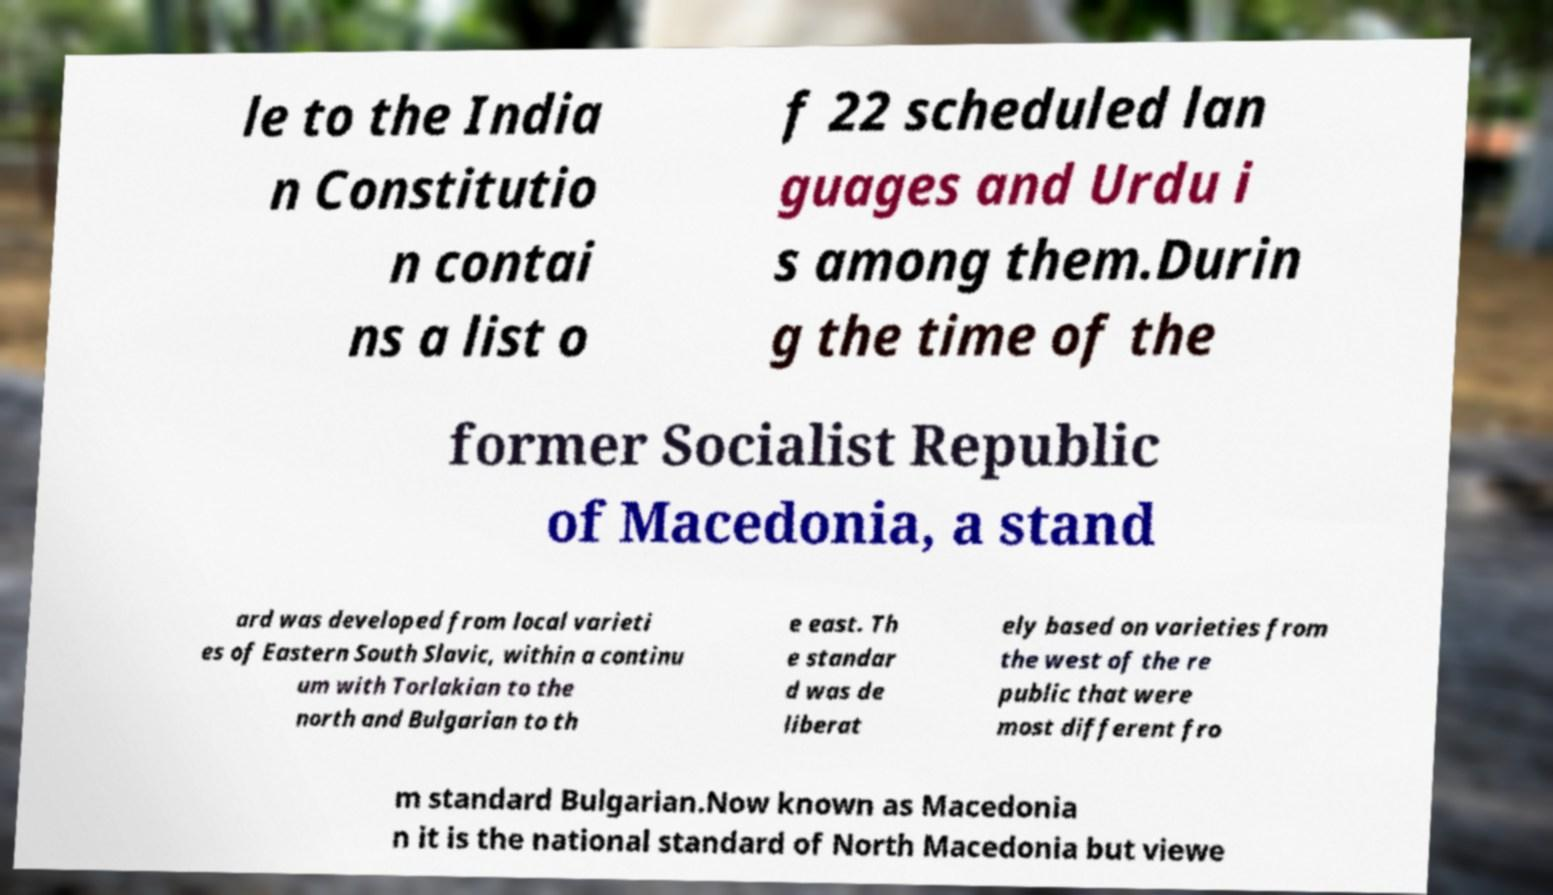Could you extract and type out the text from this image? le to the India n Constitutio n contai ns a list o f 22 scheduled lan guages and Urdu i s among them.Durin g the time of the former Socialist Republic of Macedonia, a stand ard was developed from local varieti es of Eastern South Slavic, within a continu um with Torlakian to the north and Bulgarian to th e east. Th e standar d was de liberat ely based on varieties from the west of the re public that were most different fro m standard Bulgarian.Now known as Macedonia n it is the national standard of North Macedonia but viewe 